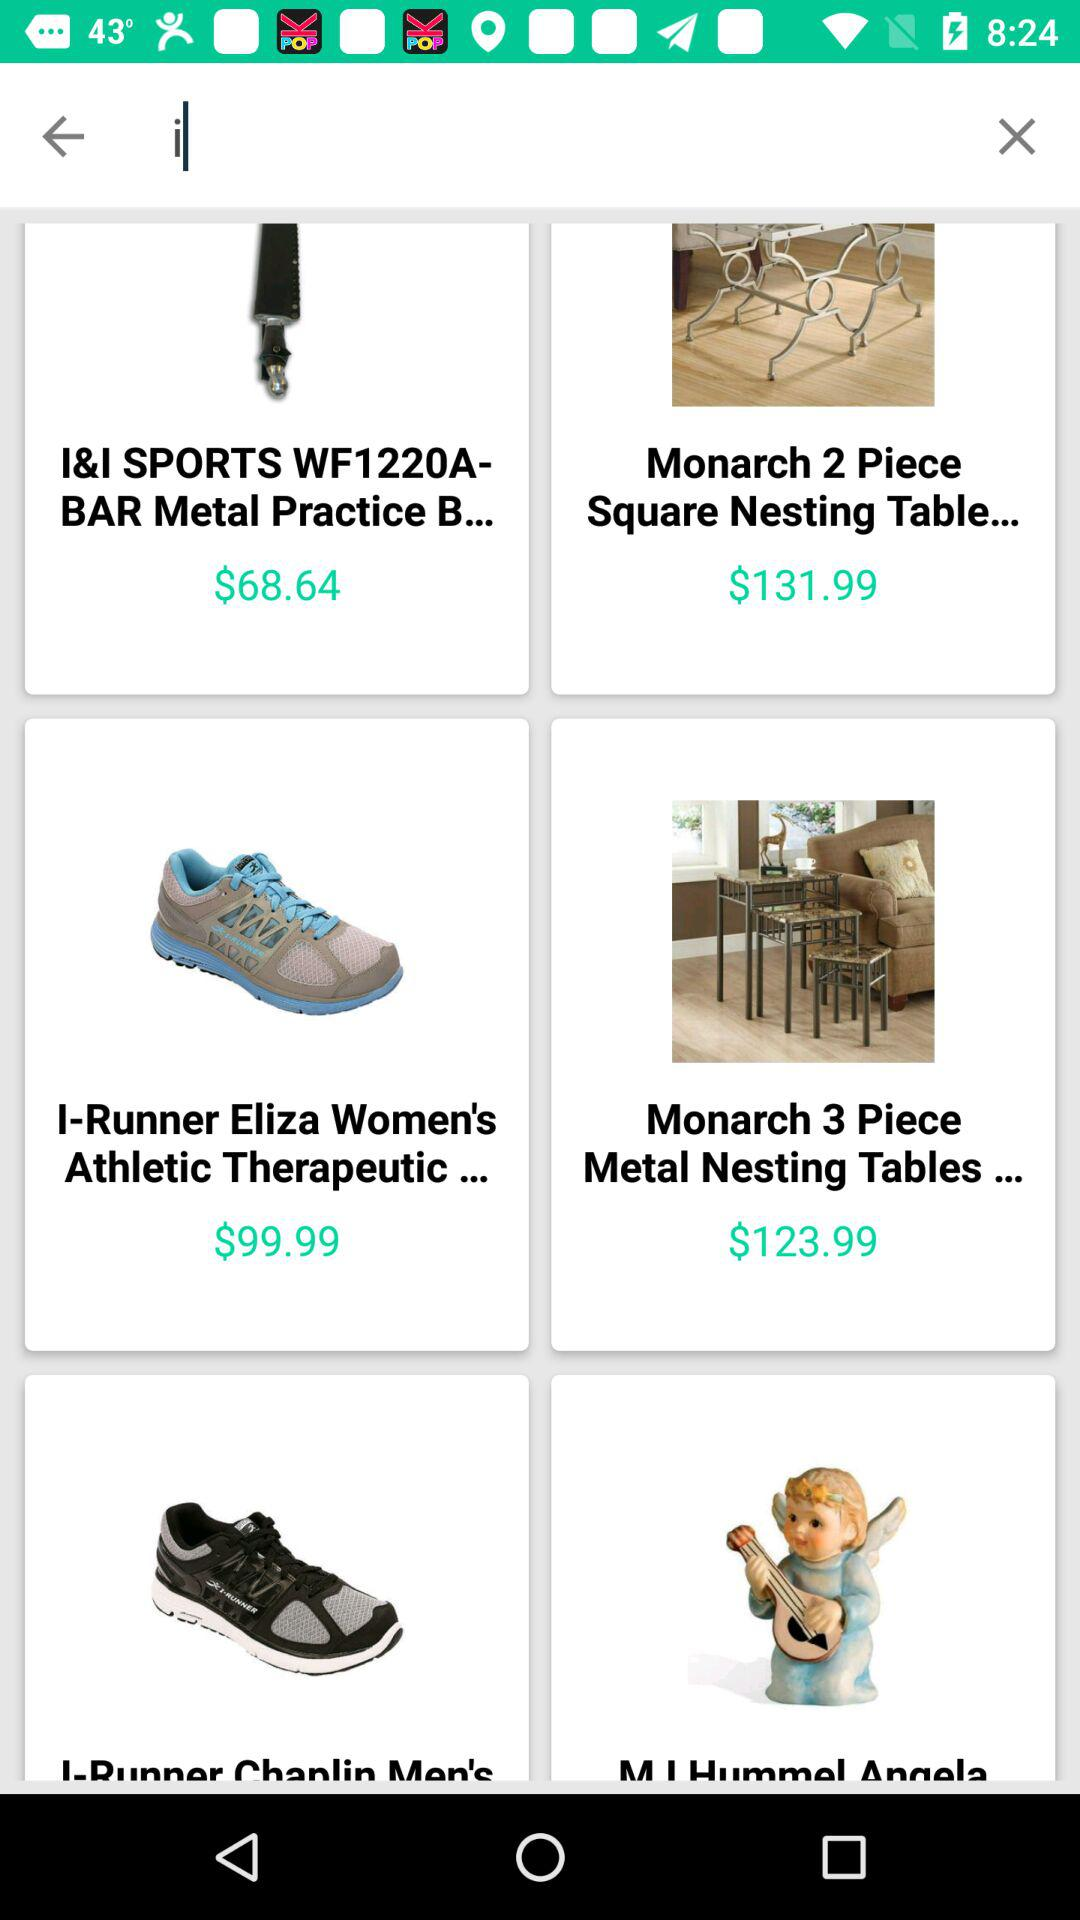What is the price of the Monarch 2 piece square nesting table? The price of the Monarch 2 piece square nesting table is $131.99. 